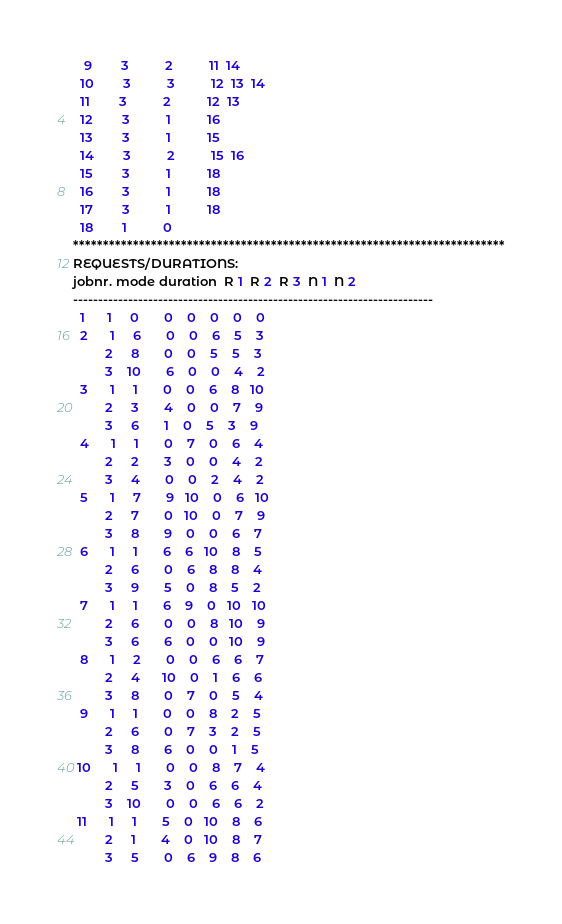<code> <loc_0><loc_0><loc_500><loc_500><_ObjectiveC_>   9        3          2          11  14
  10        3          3          12  13  14
  11        3          2          12  13
  12        3          1          16
  13        3          1          15
  14        3          2          15  16
  15        3          1          18
  16        3          1          18
  17        3          1          18
  18        1          0        
************************************************************************
REQUESTS/DURATIONS:
jobnr. mode duration  R 1  R 2  R 3  N 1  N 2
------------------------------------------------------------------------
  1      1     0       0    0    0    0    0
  2      1     6       0    0    6    5    3
         2     8       0    0    5    5    3
         3    10       6    0    0    4    2
  3      1     1       0    0    6    8   10
         2     3       4    0    0    7    9
         3     6       1    0    5    3    9
  4      1     1       0    7    0    6    4
         2     2       3    0    0    4    2
         3     4       0    0    2    4    2
  5      1     7       9   10    0    6   10
         2     7       0   10    0    7    9
         3     8       9    0    0    6    7
  6      1     1       6    6   10    8    5
         2     6       0    6    8    8    4
         3     9       5    0    8    5    2
  7      1     1       6    9    0   10   10
         2     6       0    0    8   10    9
         3     6       6    0    0   10    9
  8      1     2       0    0    6    6    7
         2     4      10    0    1    6    6
         3     8       0    7    0    5    4
  9      1     1       0    0    8    2    5
         2     6       0    7    3    2    5
         3     8       6    0    0    1    5
 10      1     1       0    0    8    7    4
         2     5       3    0    6    6    4
         3    10       0    0    6    6    2
 11      1     1       5    0   10    8    6
         2     1       4    0   10    8    7
         3     5       0    6    9    8    6</code> 